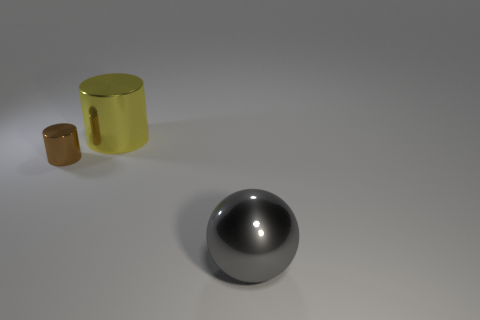Are there any other things that have the same shape as the big gray thing?
Your response must be concise. No. Are there an equal number of big metal objects that are behind the tiny brown metal cylinder and gray metal objects?
Offer a very short reply. Yes. Are there any cylinders behind the brown cylinder?
Offer a terse response. Yes. How many metallic things are tiny gray balls or tiny brown objects?
Your answer should be compact. 1. How many big yellow things are behind the tiny brown metallic cylinder?
Provide a succinct answer. 1. Are there any gray shiny balls that have the same size as the yellow metallic object?
Offer a terse response. Yes. Is there any other thing that is the same size as the brown metal cylinder?
Keep it short and to the point. No. What number of things are large green metal objects or gray metallic spheres in front of the yellow shiny object?
Provide a short and direct response. 1. What size is the metal cylinder left of the big thing that is to the left of the gray metal object?
Your answer should be very brief. Small. Are there the same number of large gray metal spheres in front of the large gray sphere and big shiny cylinders right of the small brown metal cylinder?
Give a very brief answer. No. 